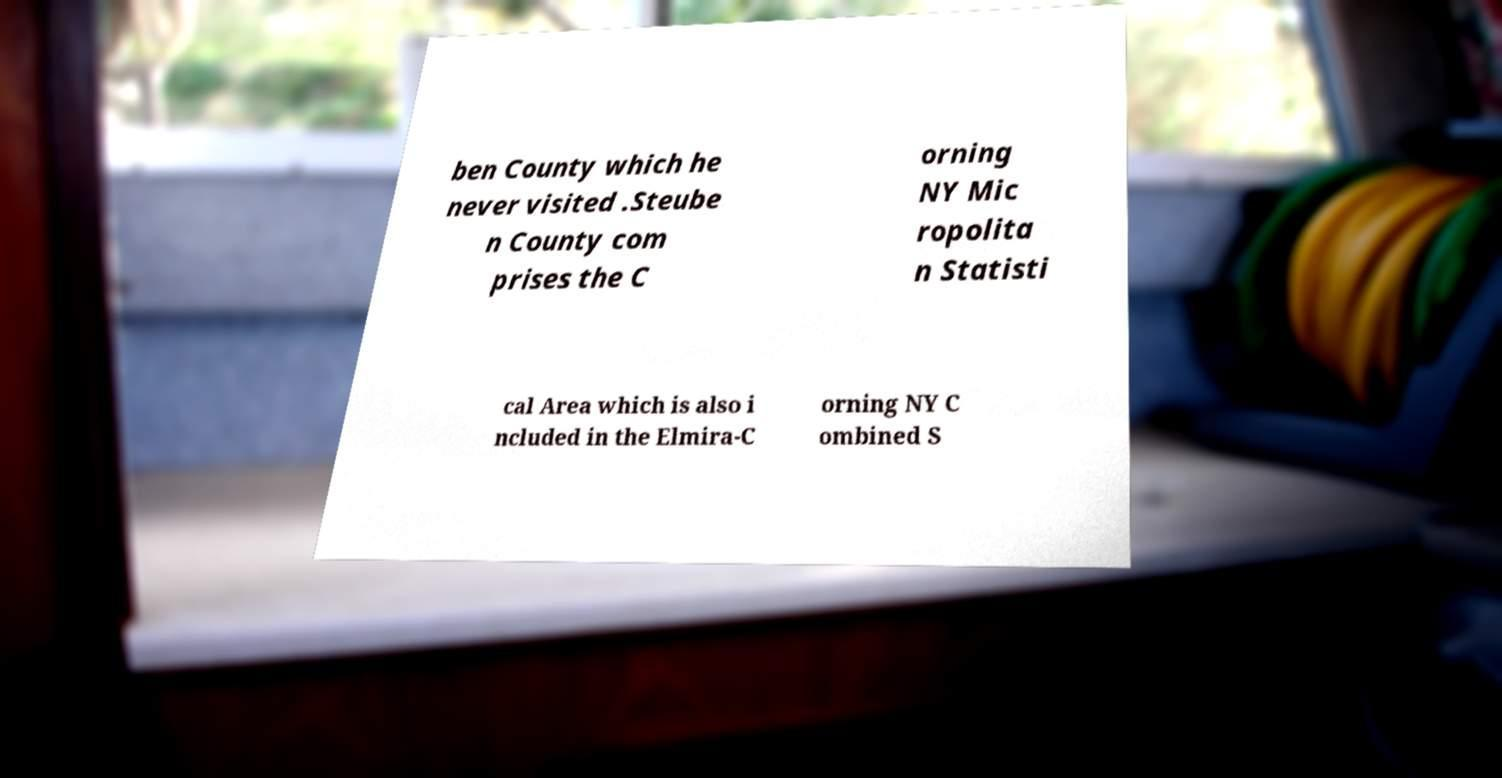Please read and relay the text visible in this image. What does it say? ben County which he never visited .Steube n County com prises the C orning NY Mic ropolita n Statisti cal Area which is also i ncluded in the Elmira-C orning NY C ombined S 